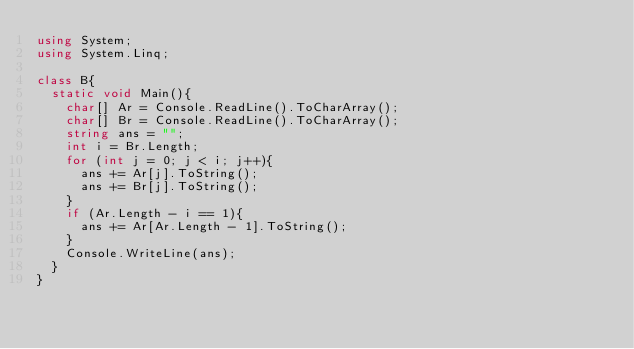Convert code to text. <code><loc_0><loc_0><loc_500><loc_500><_C#_>using System;
using System.Linq;

class B{
  static void Main(){
    char[] Ar = Console.ReadLine().ToCharArray();
    char[] Br = Console.ReadLine().ToCharArray();
    string ans = "";
    int i = Br.Length;
    for (int j = 0; j < i; j++){
      ans += Ar[j].ToString();
      ans += Br[j].ToString();
    }
    if (Ar.Length - i == 1){
      ans += Ar[Ar.Length - 1].ToString();
    }
    Console.WriteLine(ans);
  }
}</code> 